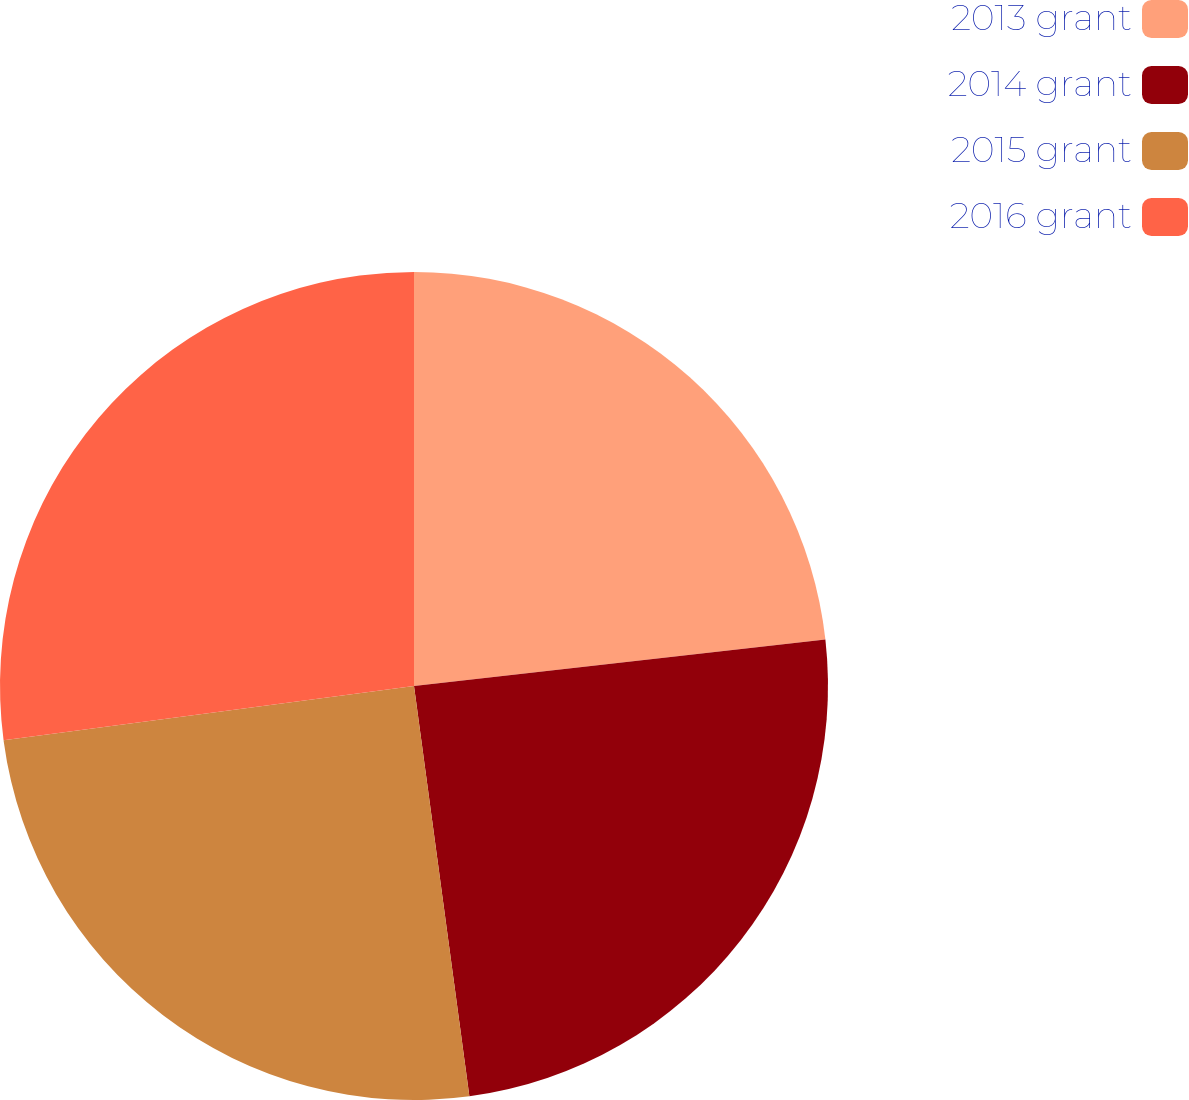<chart> <loc_0><loc_0><loc_500><loc_500><pie_chart><fcel>2013 grant<fcel>2014 grant<fcel>2015 grant<fcel>2016 grant<nl><fcel>23.21%<fcel>24.65%<fcel>25.04%<fcel>27.09%<nl></chart> 